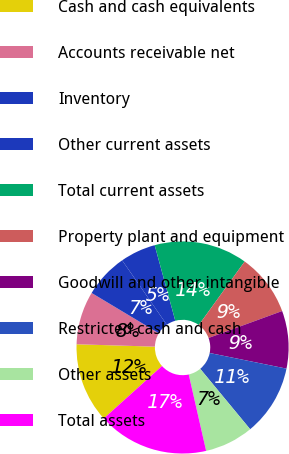Convert chart. <chart><loc_0><loc_0><loc_500><loc_500><pie_chart><fcel>Cash and cash equivalents<fcel>Accounts receivable net<fcel>Inventory<fcel>Other current assets<fcel>Total current assets<fcel>Property plant and equipment<fcel>Goodwill and other intangible<fcel>Restricted cash and cash<fcel>Other assets<fcel>Total assets<nl><fcel>12.16%<fcel>8.11%<fcel>6.76%<fcel>5.41%<fcel>14.19%<fcel>9.46%<fcel>8.78%<fcel>10.81%<fcel>7.43%<fcel>16.89%<nl></chart> 